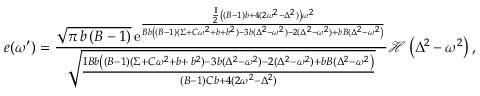Convert formula to latex. <formula><loc_0><loc_0><loc_500><loc_500>e ( \omega ^ { \prime } ) = \frac { \sqrt { \pi \, b \left ( B - 1 \right ) } \, { \mathrm e } ^ { \frac { \frac { I } { 2 } \left ( ( B - 1 ) b + 4 ( 2 \omega ^ { 2 } - \Delta ^ { 2 } ) \right ) \omega ^ { 2 } } { B b \left ( ( B - 1 ) ( \Sigma + C \omega ^ { 2 } + b + b ^ { 2 } ) - 3 b ( \Delta ^ { 2 } - \omega ^ { 2 } ) - 2 ( \Delta ^ { 2 } - \omega ^ { 2 } ) + b B ( \Delta ^ { 2 } - \omega ^ { 2 } \right ) } } } { \sqrt { \frac { I B b \left ( ( B - 1 ) ( \Sigma + C \omega ^ { 2 } + b + \, b ^ { 2 } ) - 3 b ( \Delta ^ { 2 } - \omega ^ { 2 } ) - 2 ( \Delta ^ { 2 } - \omega ^ { 2 } ) + b B ( \Delta ^ { 2 } - \omega ^ { 2 } \right ) } { ( B - 1 ) C b + 4 ( 2 \omega ^ { 2 } - \Delta ^ { 2 } ) } } } \mathcal { H } \left ( \Delta ^ { 2 } - \omega ^ { 2 } \right ) ,</formula> 